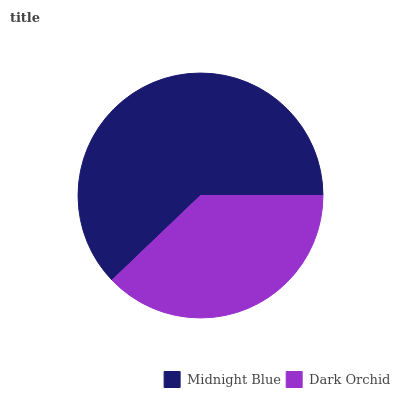Is Dark Orchid the minimum?
Answer yes or no. Yes. Is Midnight Blue the maximum?
Answer yes or no. Yes. Is Dark Orchid the maximum?
Answer yes or no. No. Is Midnight Blue greater than Dark Orchid?
Answer yes or no. Yes. Is Dark Orchid less than Midnight Blue?
Answer yes or no. Yes. Is Dark Orchid greater than Midnight Blue?
Answer yes or no. No. Is Midnight Blue less than Dark Orchid?
Answer yes or no. No. Is Midnight Blue the high median?
Answer yes or no. Yes. Is Dark Orchid the low median?
Answer yes or no. Yes. Is Dark Orchid the high median?
Answer yes or no. No. Is Midnight Blue the low median?
Answer yes or no. No. 